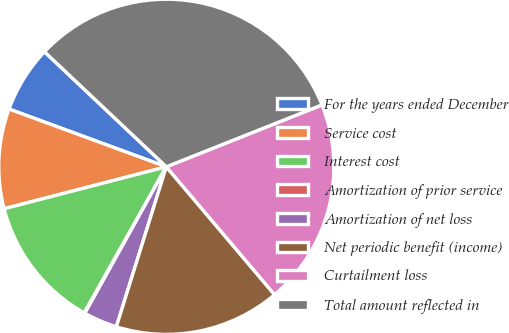Convert chart to OTSL. <chart><loc_0><loc_0><loc_500><loc_500><pie_chart><fcel>For the years ended December<fcel>Service cost<fcel>Interest cost<fcel>Amortization of prior service<fcel>Amortization of net loss<fcel>Net periodic benefit (income)<fcel>Curtailment loss<fcel>Total amount reflected in<nl><fcel>6.44%<fcel>9.63%<fcel>12.82%<fcel>0.07%<fcel>3.26%<fcel>16.0%<fcel>19.84%<fcel>31.93%<nl></chart> 